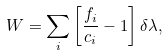<formula> <loc_0><loc_0><loc_500><loc_500>W = \sum _ { i } \left [ \frac { f _ { i } } { c _ { i } } - 1 \right ] \delta \lambda ,</formula> 